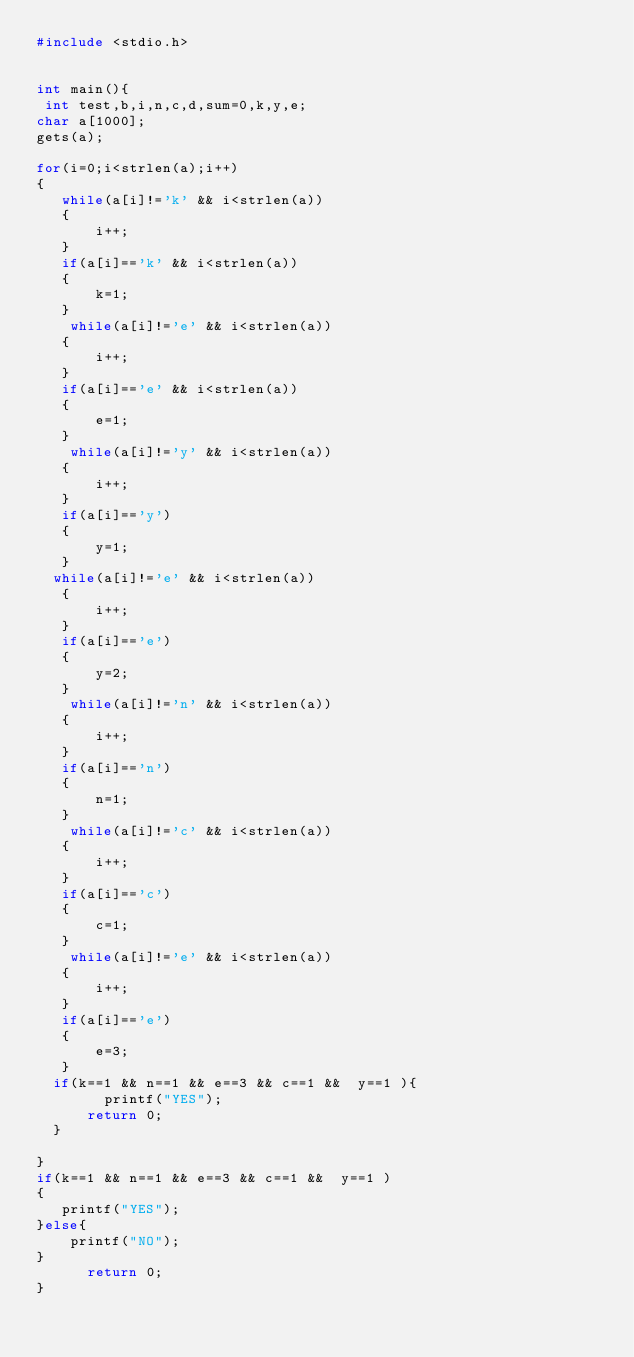<code> <loc_0><loc_0><loc_500><loc_500><_C_>#include <stdio.h>


int main(){
 int test,b,i,n,c,d,sum=0,k,y,e;
char a[1000];
gets(a);

for(i=0;i<strlen(a);i++)
{
   while(a[i]!='k' && i<strlen(a))
   {
       i++;
   }
   if(a[i]=='k' && i<strlen(a))
   {
       k=1;
   }
    while(a[i]!='e' && i<strlen(a))
   {
       i++;
   }
   if(a[i]=='e' && i<strlen(a))
   {
       e=1;
   }
    while(a[i]!='y' && i<strlen(a))
   {
       i++;
   }
   if(a[i]=='y')
   {
       y=1;
   }
  while(a[i]!='e' && i<strlen(a))
   {
       i++;
   }
   if(a[i]=='e')
   {
       y=2;
   }
    while(a[i]!='n' && i<strlen(a))
   {
       i++;
   }
   if(a[i]=='n')
   {
       n=1;
   }
    while(a[i]!='c' && i<strlen(a))
   {
       i++;
   }
   if(a[i]=='c')
   {
       c=1;
   }
    while(a[i]!='e' && i<strlen(a))
   {
       i++;
   }
   if(a[i]=='e')
   {
       e=3;
   }
  if(k==1 && n==1 && e==3 && c==1 &&  y==1 ){
        printf("YES");
      return 0;
  }
   
}
if(k==1 && n==1 && e==3 && c==1 &&  y==1 )
{
   printf("YES");
}else{
    printf("NO");
}
      return 0;
}
</code> 